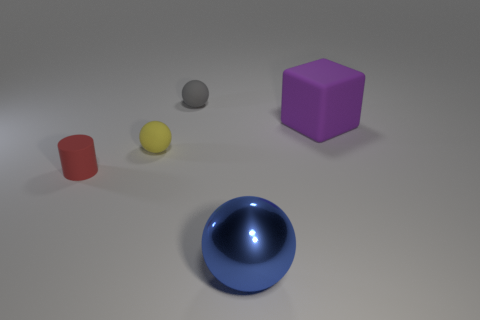Are the tiny object that is behind the tiny yellow ball and the big sphere made of the same material?
Your answer should be very brief. No. Is the number of large blocks that are in front of the tiny yellow ball the same as the number of tiny yellow spheres behind the metallic sphere?
Ensure brevity in your answer.  No. There is another gray object that is the same shape as the big shiny object; what is it made of?
Your answer should be compact. Rubber. Is there a cylinder that is on the left side of the tiny sphere left of the ball behind the tiny yellow ball?
Your answer should be compact. Yes. Do the tiny object behind the tiny yellow sphere and the large blue metallic object in front of the tiny gray sphere have the same shape?
Your answer should be very brief. Yes. Is the number of tiny objects that are in front of the tiny yellow matte object greater than the number of big gray rubber balls?
Give a very brief answer. Yes. How many objects are large purple cubes or cylinders?
Offer a terse response. 2. What color is the small rubber cylinder?
Offer a terse response. Red. How many other objects are the same color as the big block?
Provide a succinct answer. 0. There is a blue thing; are there any red cylinders to the left of it?
Your response must be concise. Yes. 